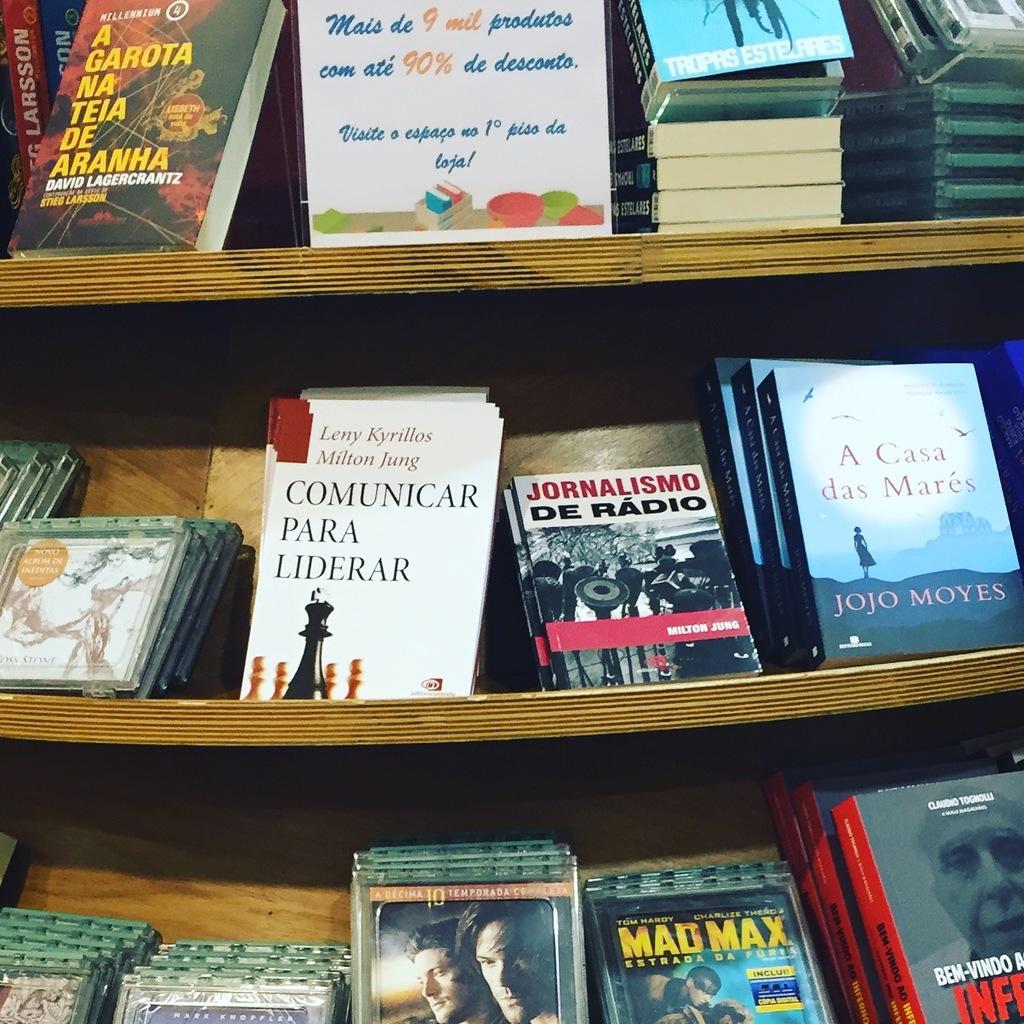Do you understand the writing on the book covers?
Your answer should be compact. Yes. What famous movie can be seen in the bottom row in yellow letters?
Ensure brevity in your answer.  Mad max. 